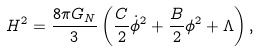<formula> <loc_0><loc_0><loc_500><loc_500>H ^ { 2 } = \frac { 8 \pi G _ { N } } { 3 } \left ( \frac { C } { 2 } \dot { \phi } ^ { 2 } + \frac { B } { 2 } \phi ^ { 2 } + \Lambda \right ) ,</formula> 